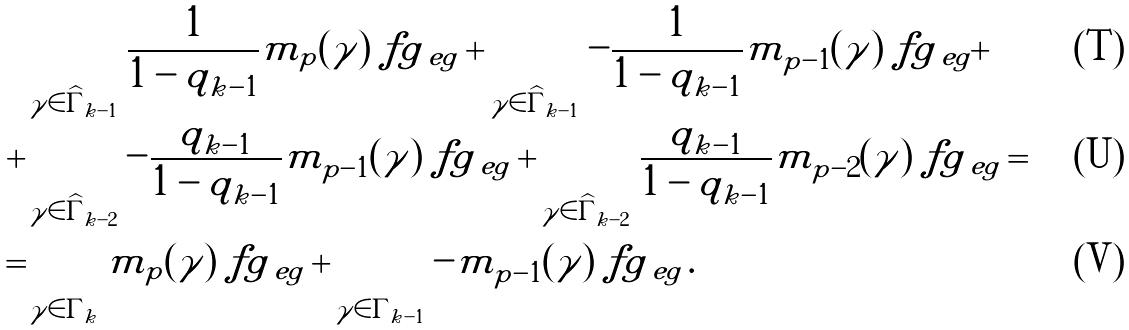Convert formula to latex. <formula><loc_0><loc_0><loc_500><loc_500>& \sum _ { \gamma \in \widehat { \Gamma } _ { k - 1 } } \frac { 1 } { 1 - q _ { k - 1 } } m _ { p } ( \gamma ) \ f g _ { \ e g } + \sum _ { \gamma \in \widehat { \Gamma } _ { k - 1 } } - \frac { 1 } { 1 - q _ { k - 1 } } m _ { p - 1 } ( \gamma ) \ f g _ { \ e g } + \\ + & \sum _ { \gamma \in \widehat { \Gamma } _ { k - 2 } } - \frac { q _ { k - 1 } } { 1 - q _ { k - 1 } } m _ { p - 1 } ( \gamma ) \ f g _ { \ e g } + \sum _ { \gamma \in \widehat { \Gamma } _ { k - 2 } } \frac { q _ { k - 1 } } { 1 - q _ { k - 1 } } m _ { p - 2 } ( \gamma ) \ f g _ { \ e g } = \\ = & \sum _ { \gamma \in \Gamma _ { k } } m _ { p } ( \gamma ) \ f g _ { \ e g } + \sum _ { \gamma \in \Gamma _ { k - 1 } } - m _ { p - 1 } ( \gamma ) \ f g _ { \ e g } \, .</formula> 